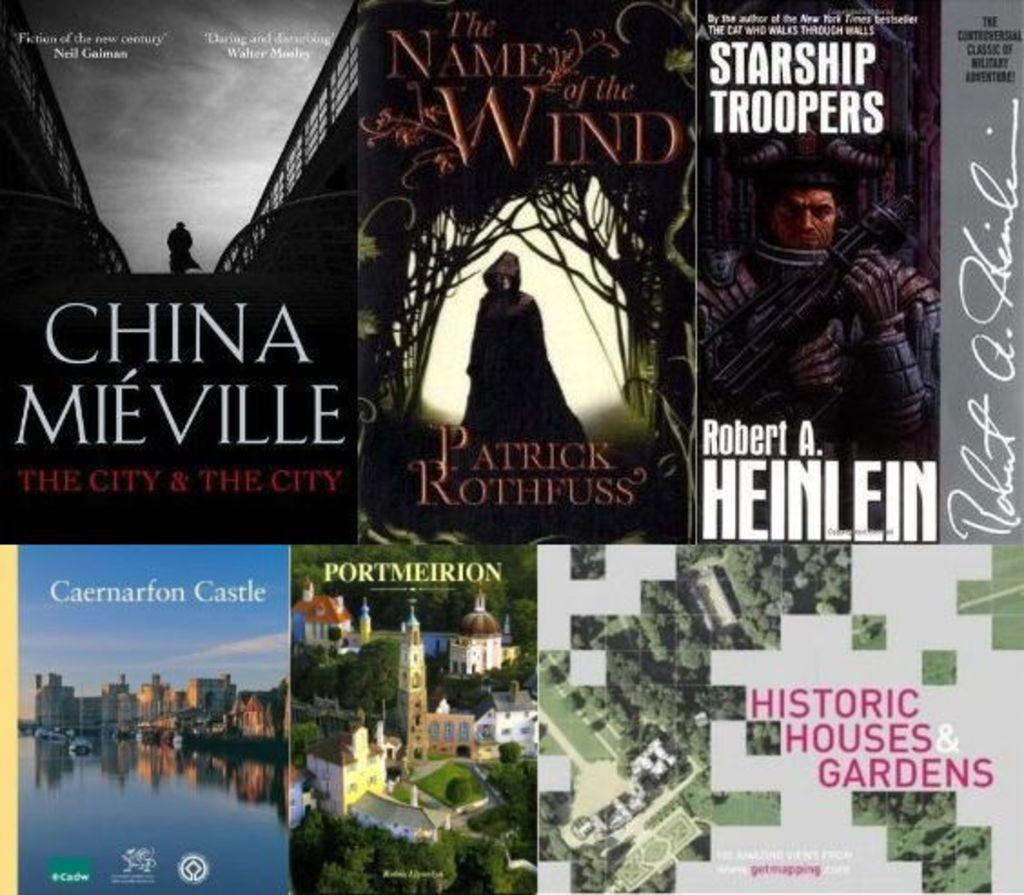<image>
Describe the image concisely. some books that include CHINA MIEVILLE, starship troopers and OTHERS. 